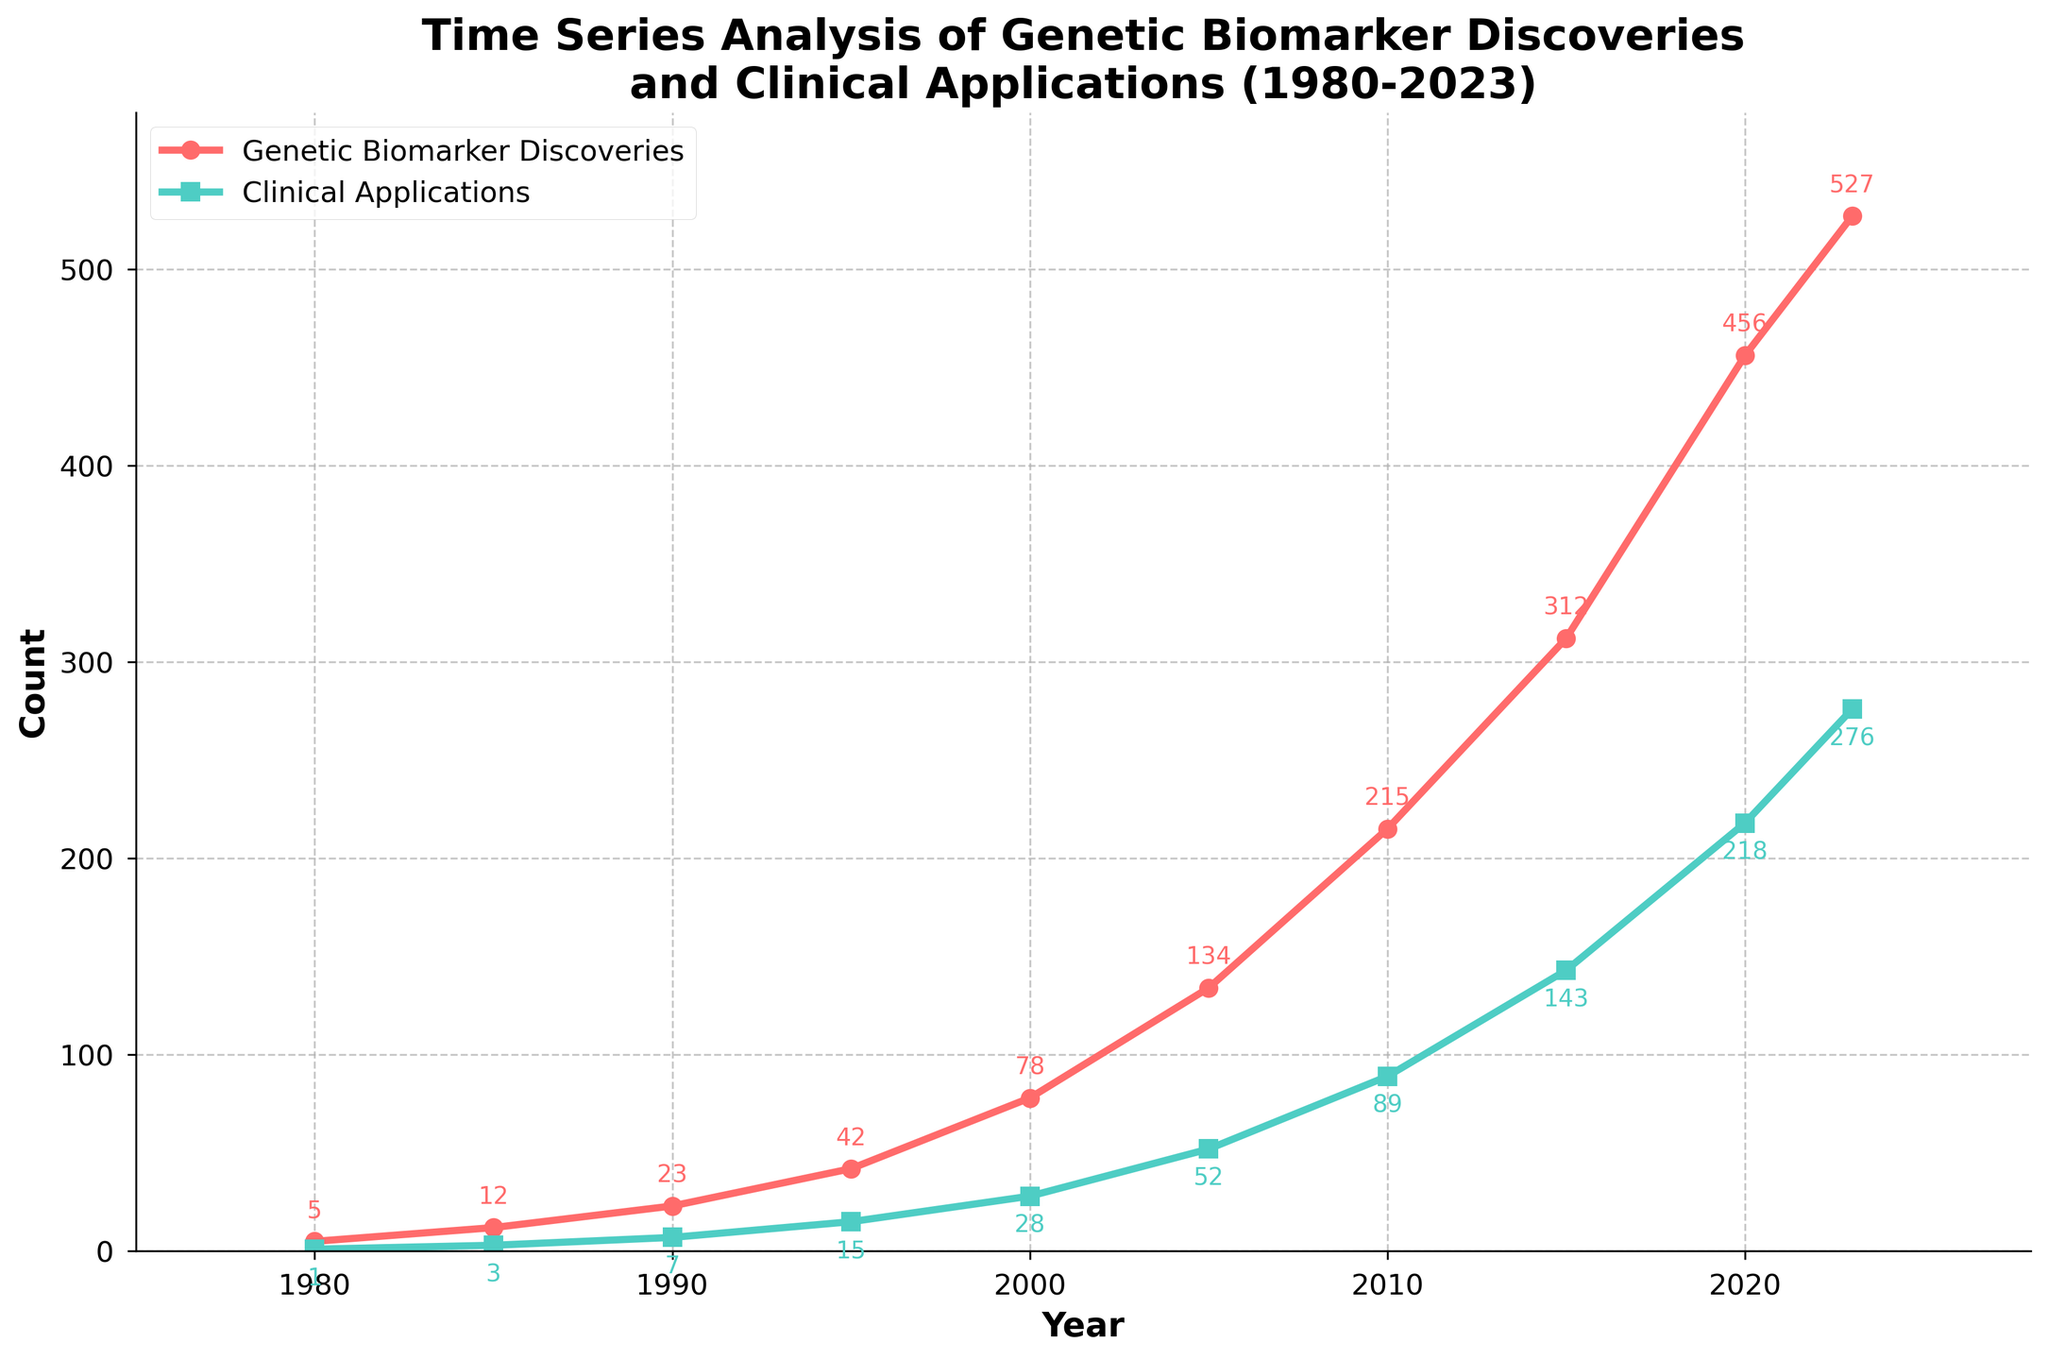What is the total number of genetic biomarker discoveries made from 1980 to 2023? Sum all the data points for genetic biomarker discoveries: 5 + 12 + 23 + 42 + 78 + 134 + 215 + 312 + 456 + 527 = 1804
Answer: 1804 Which year saw the highest increase in clinical applications compared to the preceding period? Compute the differences in clinical applications between consecutive years and find the maximum: 
(3-1) = 2, (7-3) = 4, (15-7) = 8, (28-15) = 13, (52-28) = 24, (89-52) = 37, (143-89) = 54, (218-143) = 75, (276-218) = 58. The highest increase is between 2015 and 2020, which is 75
Answer: 2015-2020 What is the ratio of clinical applications to genetic biomarker discoveries in 2000? Divide the number of clinical applications by the number of genetic biomarker discoveries in 2000: 28 / 78 ≈ 0.36
Answer: 0.36 How many more genetic biomarker discoveries were made in 2010 compared to 2005? Subtract the number of genetic biomarker discoveries in 2005 from 2010: 215 - 134 = 81
Answer: 81 In which year were there approximately twice as many genetic biomarker discoveries as clinical applications? Check each year to see if the number of genetic biomarker discoveries is roughly double the number of clinical applications. For 2023, 527 discoveries and 276 applications is approximately 2 times 276: 527 ≈ 2 * 276
Answer: 2023 Which dataset (genetic biomarker discoveries or clinical applications) shows a higher growth from 1980 to 2023? Compare the growth from 1980 to 2023 for both datasets: 
For genetic biomarker discoveries: 5 to 527 
For clinical applications: 1 to 276 
527/5 ≈ 105.4, 276/1 = 276. The clinical applications show higher growth despite appearing less at face value.
Answer: Clinical applications Between which consecutive years did genetic biomarker discoveries see the largest percentage increase? Calculate the percentage increase for each consecutive interval: 
((12-5)/5)*100 = 140%, ((23-12)/12)*100 ≈ 91.67%, ((42-23)/23)*100 ≈ 82.61%, ((78-42)/42)*100 ≈ 85.71%, ((134-78)/78)*100 ≈ 71.79%, ((215-134)/134)*100 ≈ 60.45%, ((312-215)/215)*100 ≈ 45.12%, ((456-312)/312)*100 ≈ 46.15%, ((527-456)/456)*100 ≈ 15.58%. The highest increase is from 1980 to 1985.
Answer: 1980-1985 In 1995, were the clinical applications closer to the counts in 1990 or 2000? Calculate the absolute differences:
(7-15) = 8, (28-15) = 13. The clinical applications in 1995 are closer to the count in 1990.
Answer: 1990 